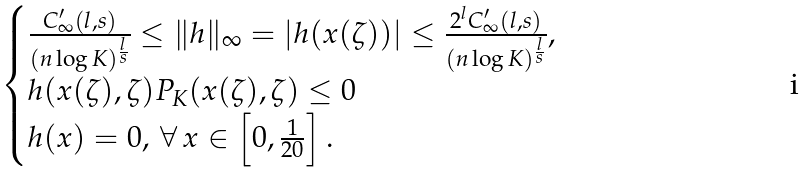Convert formula to latex. <formula><loc_0><loc_0><loc_500><loc_500>\begin{cases} \frac { C ^ { \prime } _ { \infty } ( l , s ) } { ( n \log K ) ^ { \frac { l } { s } } } \leq \| h \| _ { \infty } = | h ( x ( \zeta ) ) | \leq \frac { 2 ^ { l } C ^ { \prime } _ { \infty } ( l , s ) } { ( n \log K ) ^ { \frac { l } { s } } } , \\ h ( x ( \zeta ) , \zeta ) P _ { K } ( x ( \zeta ) , \zeta ) \leq 0 \\ h ( x ) = 0 , \, \forall \, x \in \left [ 0 , \frac { 1 } { 2 0 } \right ] . \end{cases}</formula> 